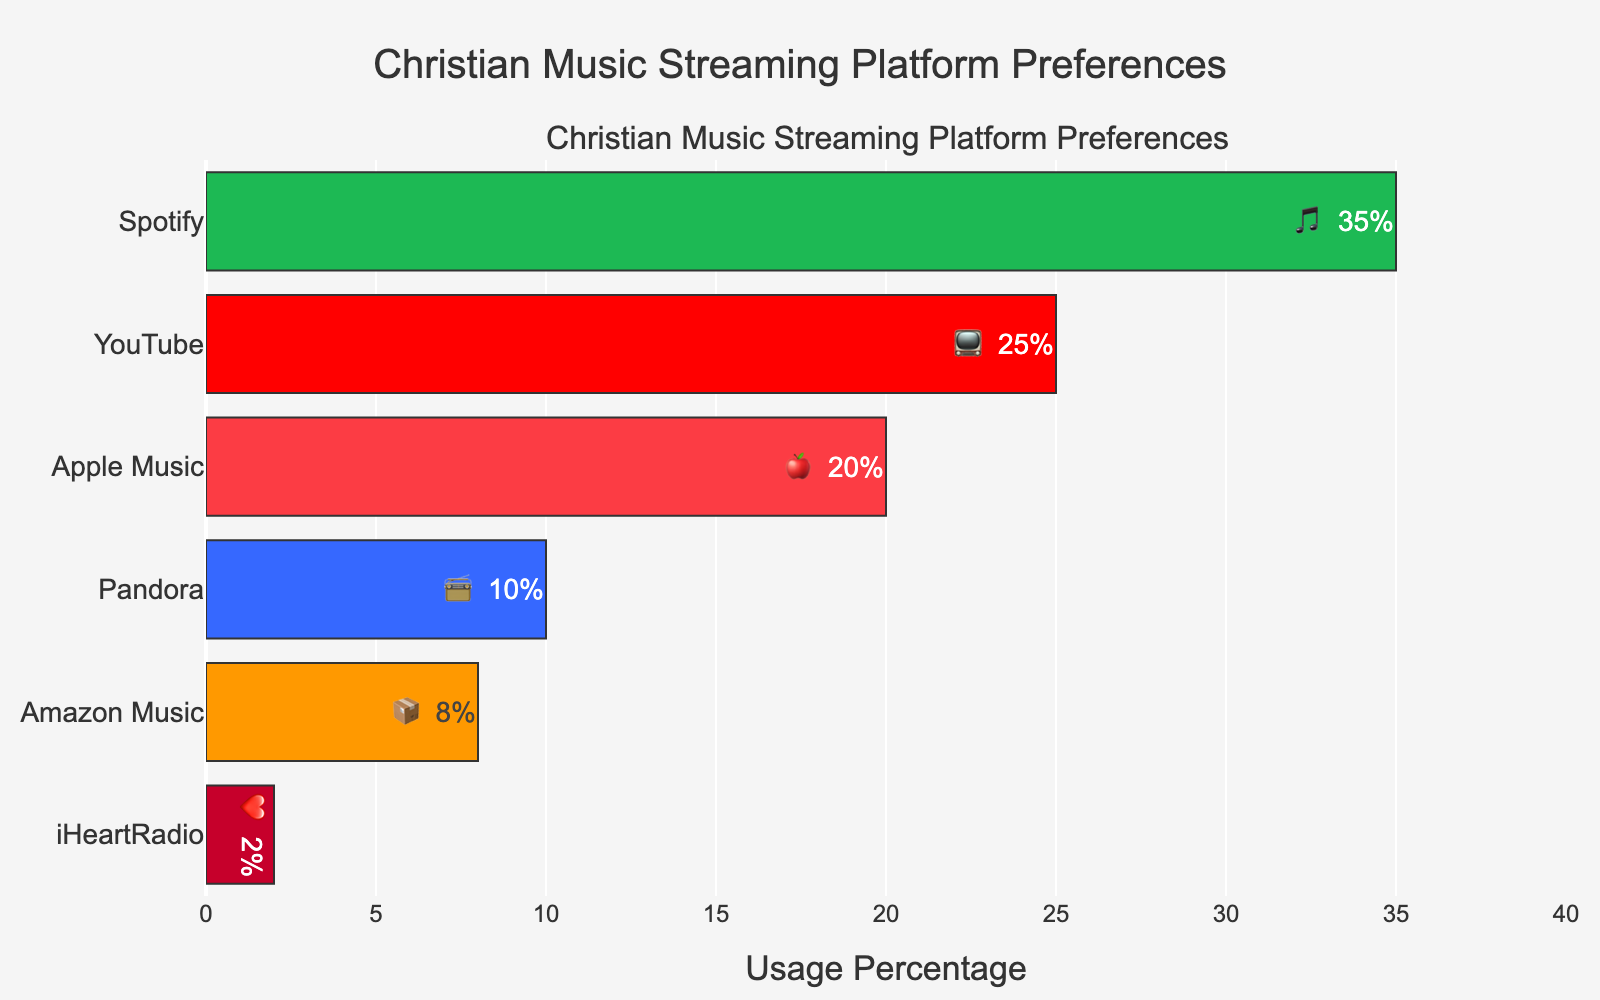Which streaming platform has the highest usage percentage? The bar for Spotify is the longest, and it shows 35%.
Answer: Spotify What is the usage percentage for YouTube? The bar labeled YouTube shows a percentage of 25% along with a TV emoji.
Answer: 25% How many platforms have a usage percentage below 10%? By scanning the bars, Pandora (10%), Amazon Music (8%), and iHeartRadio (2%) are below 10%. There are 2 platforms.
Answer: 2 What is the difference in usage percentage between Spotify and Apple Music? Spotify has 35%, and Apple Music has 20%. Subtract 20 from 35.
Answer: 15% Which platform has the 📦 emoji and what is its usage percentage? The bar with the 📦 emoji corresponds to Amazon Music, showing a percentage of 8%.
Answer: Amazon Music, 8% What are the two least used platforms? iHeartRadio and Amazon Music have the lowest usage percentages, 2% and 8% respectively, observed from their corresponding bars.
Answer: iHeartRadio and Amazon Music If you combine the usage percentages of Apple Music and Pandora, what total would you get? Apple Music has 20%, and Pandora has 10%. Adding these together gives 20 + 10.
Answer: 30% Which platform is represented by the 🍎 emoji, and what is its usage percentage? The 🍎 emoji corresponds to Apple Music, which has a usage percentage of 20%.
Answer: Apple Music, 20% Is there any platform that has a usage percentage exactly 3 times that of iHeartRadio? iHeartRadio’s usage percentage is 2%. 3 times 2% is 6%. No platform shows a percentage of 6%, confirmed by checking all bars.
Answer: No 